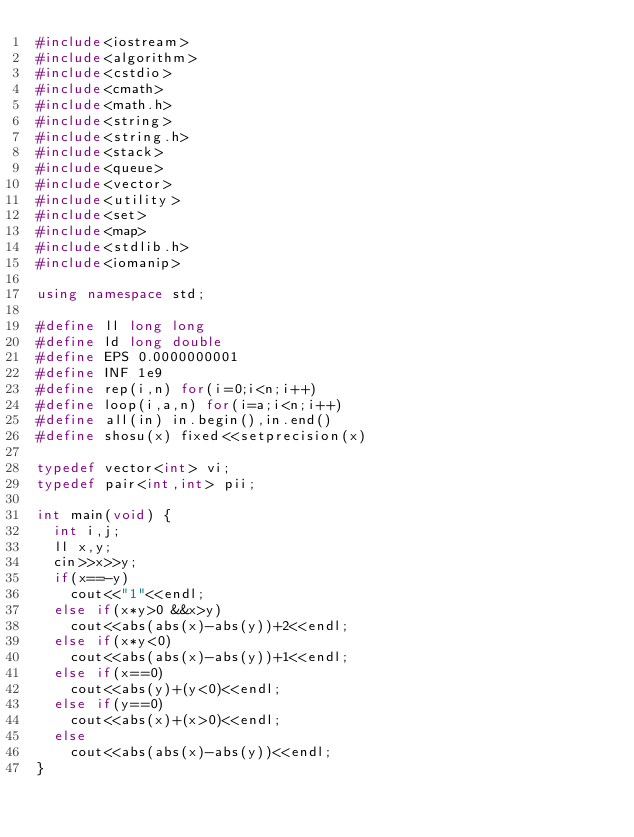Convert code to text. <code><loc_0><loc_0><loc_500><loc_500><_C++_>#include<iostream>
#include<algorithm>
#include<cstdio>
#include<cmath>
#include<math.h>
#include<string>
#include<string.h>
#include<stack>
#include<queue>
#include<vector>
#include<utility>
#include<set>
#include<map>
#include<stdlib.h>
#include<iomanip>

using namespace std;

#define ll long long
#define ld long double
#define EPS 0.0000000001
#define INF 1e9
#define rep(i,n) for(i=0;i<n;i++)
#define loop(i,a,n) for(i=a;i<n;i++)
#define all(in) in.begin(),in.end()
#define shosu(x) fixed<<setprecision(x)

typedef vector<int> vi;
typedef pair<int,int> pii;

int main(void) {
  int i,j;
  ll x,y;
  cin>>x>>y;
  if(x==-y)
    cout<<"1"<<endl;
  else if(x*y>0 &&x>y)
    cout<<abs(abs(x)-abs(y))+2<<endl;
  else if(x*y<0)
    cout<<abs(abs(x)-abs(y))+1<<endl;
  else if(x==0)
    cout<<abs(y)+(y<0)<<endl;
  else if(y==0)
    cout<<abs(x)+(x>0)<<endl;
  else
    cout<<abs(abs(x)-abs(y))<<endl;
}
</code> 